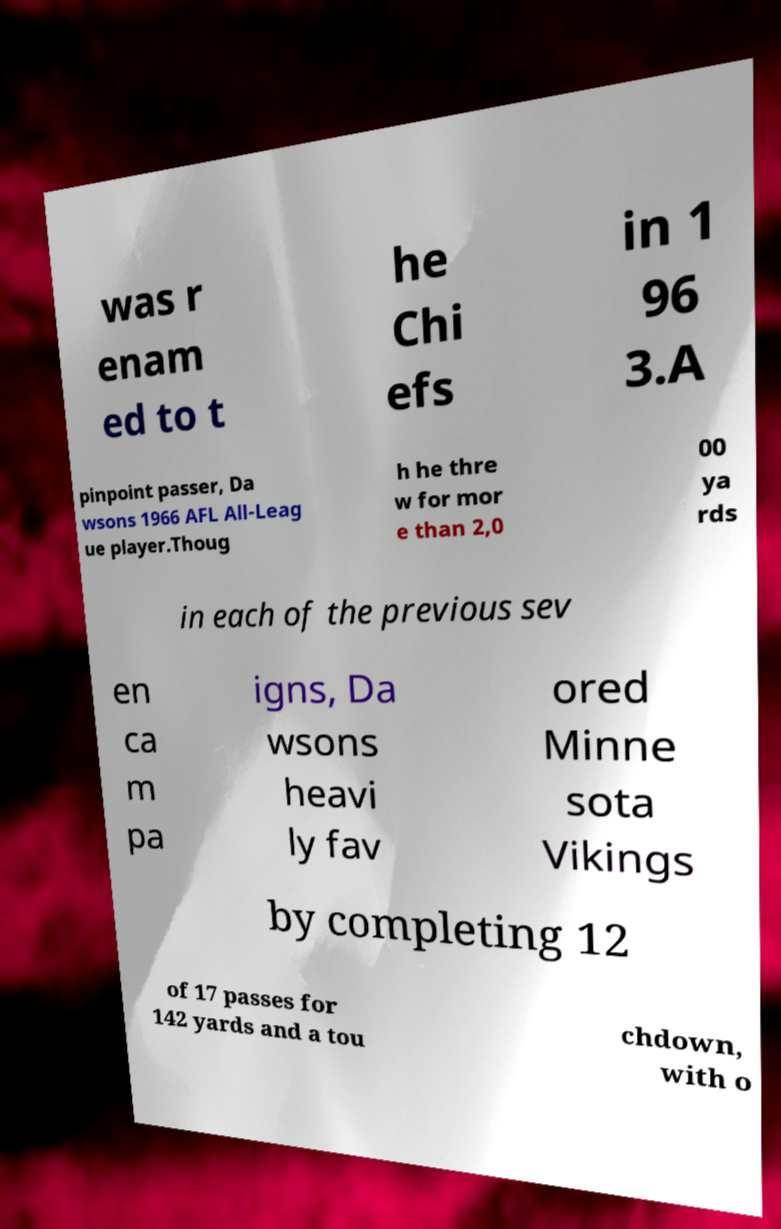For documentation purposes, I need the text within this image transcribed. Could you provide that? was r enam ed to t he Chi efs in 1 96 3.A pinpoint passer, Da wsons 1966 AFL All-Leag ue player.Thoug h he thre w for mor e than 2,0 00 ya rds in each of the previous sev en ca m pa igns, Da wsons heavi ly fav ored Minne sota Vikings by completing 12 of 17 passes for 142 yards and a tou chdown, with o 